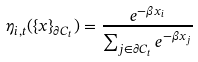<formula> <loc_0><loc_0><loc_500><loc_500>\eta _ { i , t } ( \{ x \} _ { \partial C _ { t } } ) = \frac { e ^ { - \beta x _ { i } } } { \sum _ { j \in \partial C _ { t } } e ^ { - \beta x _ { j } } }</formula> 